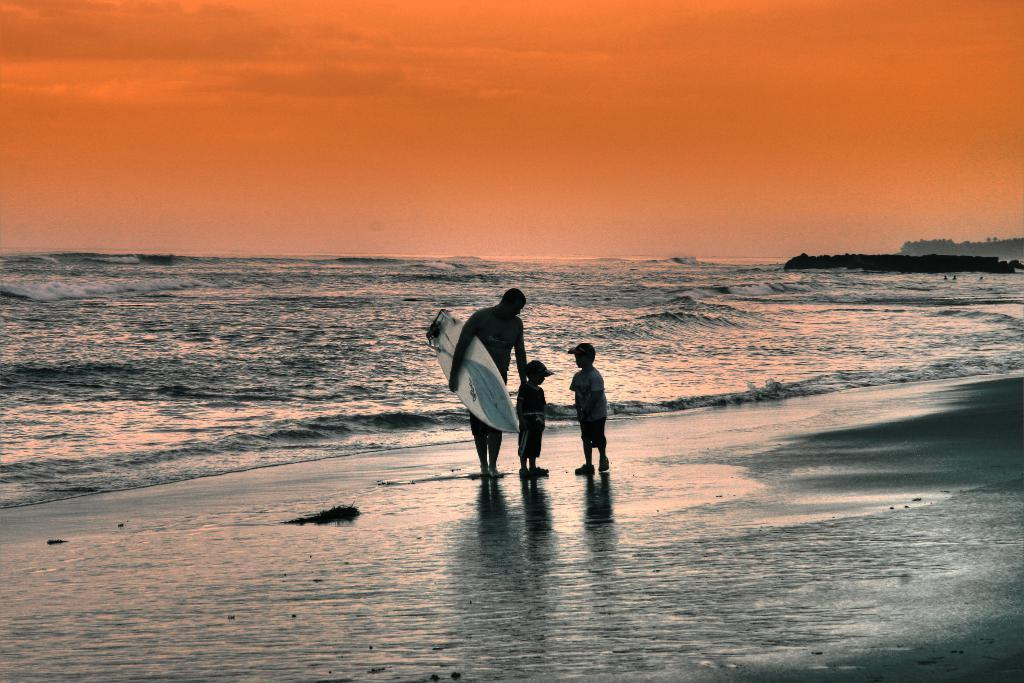What is the setting of the image? The image is set near the sea. What are the people near the sea doing? A man is holding a surfboard. What can be seen in the background of the image? The sky is visible in the background of the image. How many cacti can be seen near the sea in the image? There are no cacti present in the image; it is set near the sea with people and a man holding a surfboard. What type of footwear is the man wearing while holding the surfboard? The image does not show the man's footwear, so it cannot be determined from the picture. 